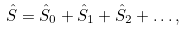<formula> <loc_0><loc_0><loc_500><loc_500>\hat { S } = \hat { S } _ { 0 } + \hat { S } _ { 1 } + \hat { S } _ { 2 } + \dots ,</formula> 